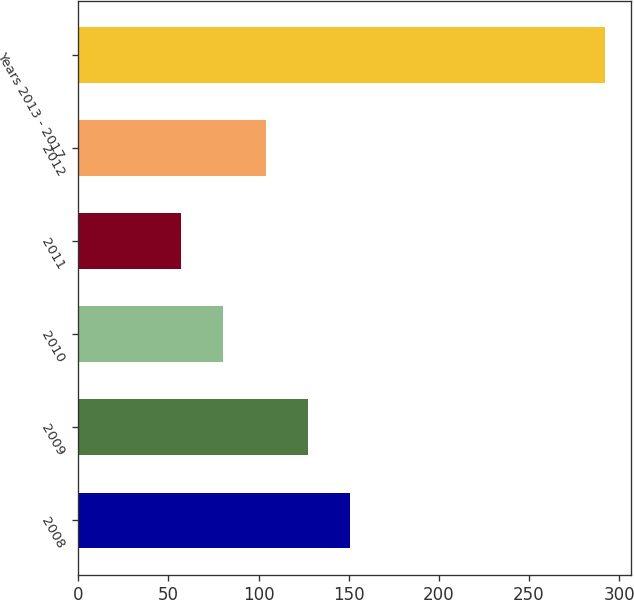Convert chart. <chart><loc_0><loc_0><loc_500><loc_500><bar_chart><fcel>2008<fcel>2009<fcel>2010<fcel>2011<fcel>2012<fcel>Years 2013 - 2017<nl><fcel>150.88<fcel>127.36<fcel>80.32<fcel>56.8<fcel>103.84<fcel>292<nl></chart> 